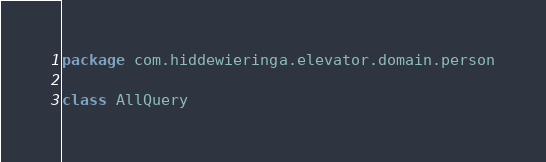Convert code to text. <code><loc_0><loc_0><loc_500><loc_500><_Kotlin_>package com.hiddewieringa.elevator.domain.person

class AllQuery
</code> 